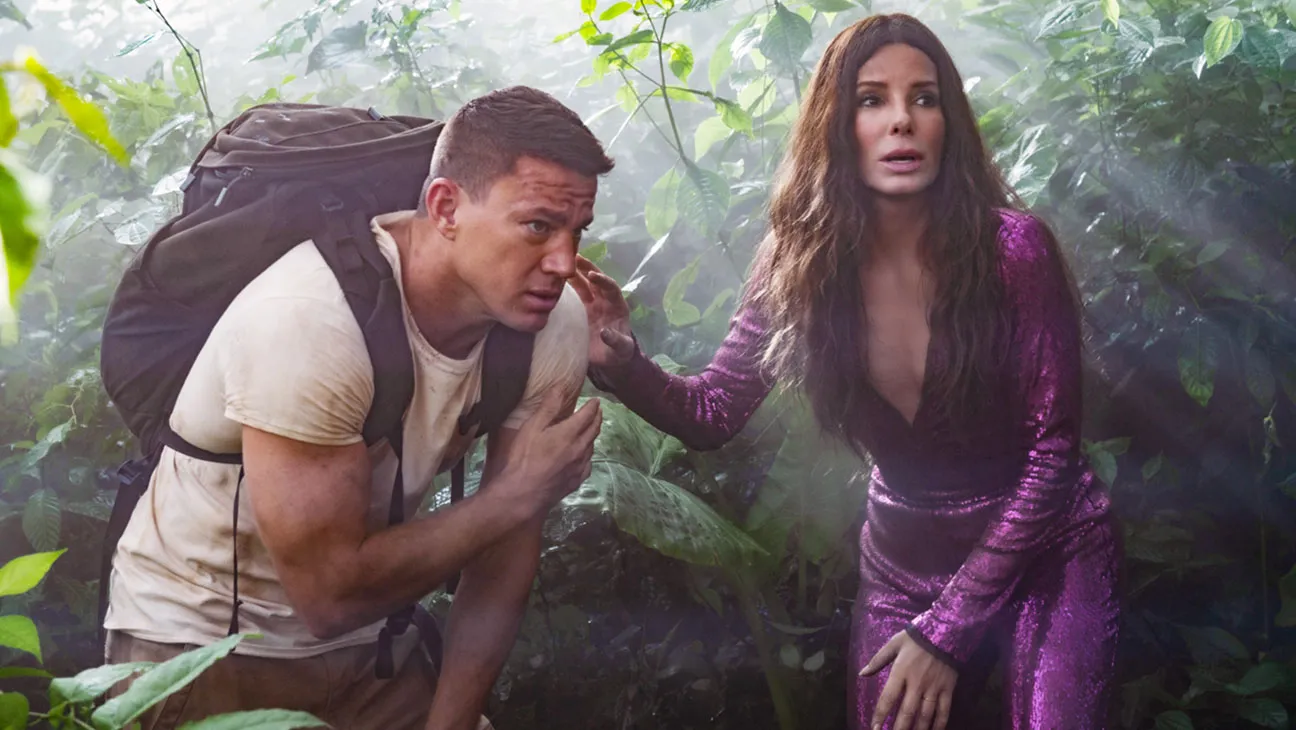What are Sandra Bullock and Channing Tatum doing in the jungle? Sandra Bullock and Channing Tatum appear to be on an adventurous quest in the jungle. Their expressions show concern and alertness, hinting at possible dangers or challenges ahead. This scene might be from a crucial moment in their adventure, where they are navigating the dense foliage in search of something or trying to escape a perilous situation. Do you think they are looking for treasure? It's quite possible! Given the adventurous theme suggested by their appearance and the jungle setting, they could indeed be in search of some hidden treasure or ancient artifact. The intensity in their expressions adds to the sense of urgency and purpose behind their mission. Whether they're treasure hunters or on a rescue mission, the scene is rich with possibilities. Imagine them finding a lost city. Describe it. Emerging from the dense foliage, Sandra Bullock and Channing Tatum stumble upon an awe-inspiring sight – a lost city shrouded in mystery and splendor. Ancient stone structures rise majestically from the jungle floor, their surfaces adorned with intricate carvings depicting forgotten histories. Vines and roots intertwine with the ancient architecture, reclaiming the once-great city back into nature's embrace. The air is thick with the scent of damp earth and blooming exotic flowers. As sunlight pierces through the canopy, it illuminates patches of gold and precious gems embedded within the stone walls, hinting at untold riches. Enormous statues of long-lost deities stand sentry, guarding the city's secrets. A sense of wonder and awe fills our adventurers as they traverse this hidden gem, pondering the civilization that once thrived here and the treasures that may lie within. 